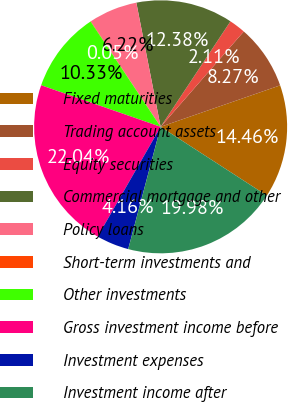<chart> <loc_0><loc_0><loc_500><loc_500><pie_chart><fcel>Fixed maturities<fcel>Trading account assets<fcel>Equity securities<fcel>Commercial mortgage and other<fcel>Policy loans<fcel>Short-term investments and<fcel>Other investments<fcel>Gross investment income before<fcel>Investment expenses<fcel>Investment income after<nl><fcel>14.46%<fcel>8.27%<fcel>2.11%<fcel>12.38%<fcel>6.22%<fcel>0.05%<fcel>10.33%<fcel>22.04%<fcel>4.16%<fcel>19.98%<nl></chart> 